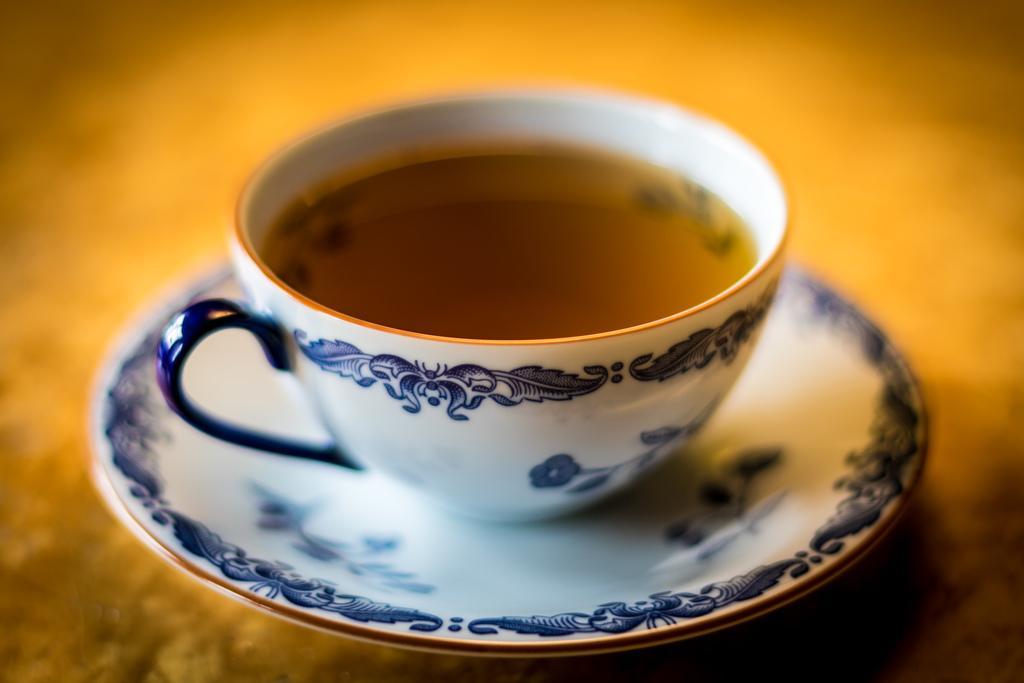Could you give a brief overview of what you see in this image? In this picture, we see the cup containing the liquid is placed in the saucer. It might be placed on the table. In the background, it is yellow in color. This picture is blurred in the background. 